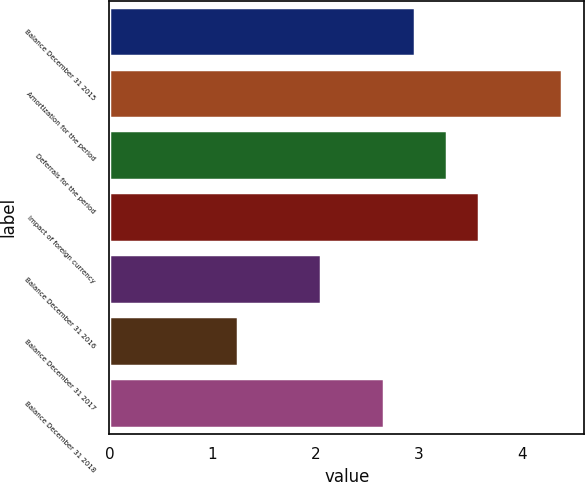<chart> <loc_0><loc_0><loc_500><loc_500><bar_chart><fcel>Balance December 31 2015<fcel>Amortization for the period<fcel>Deferrals for the period<fcel>Impact of foreign currency<fcel>Balance December 31 2016<fcel>Balance December 31 2017<fcel>Balance December 31 2018<nl><fcel>2.97<fcel>4.39<fcel>3.28<fcel>3.59<fcel>2.05<fcel>1.25<fcel>2.66<nl></chart> 